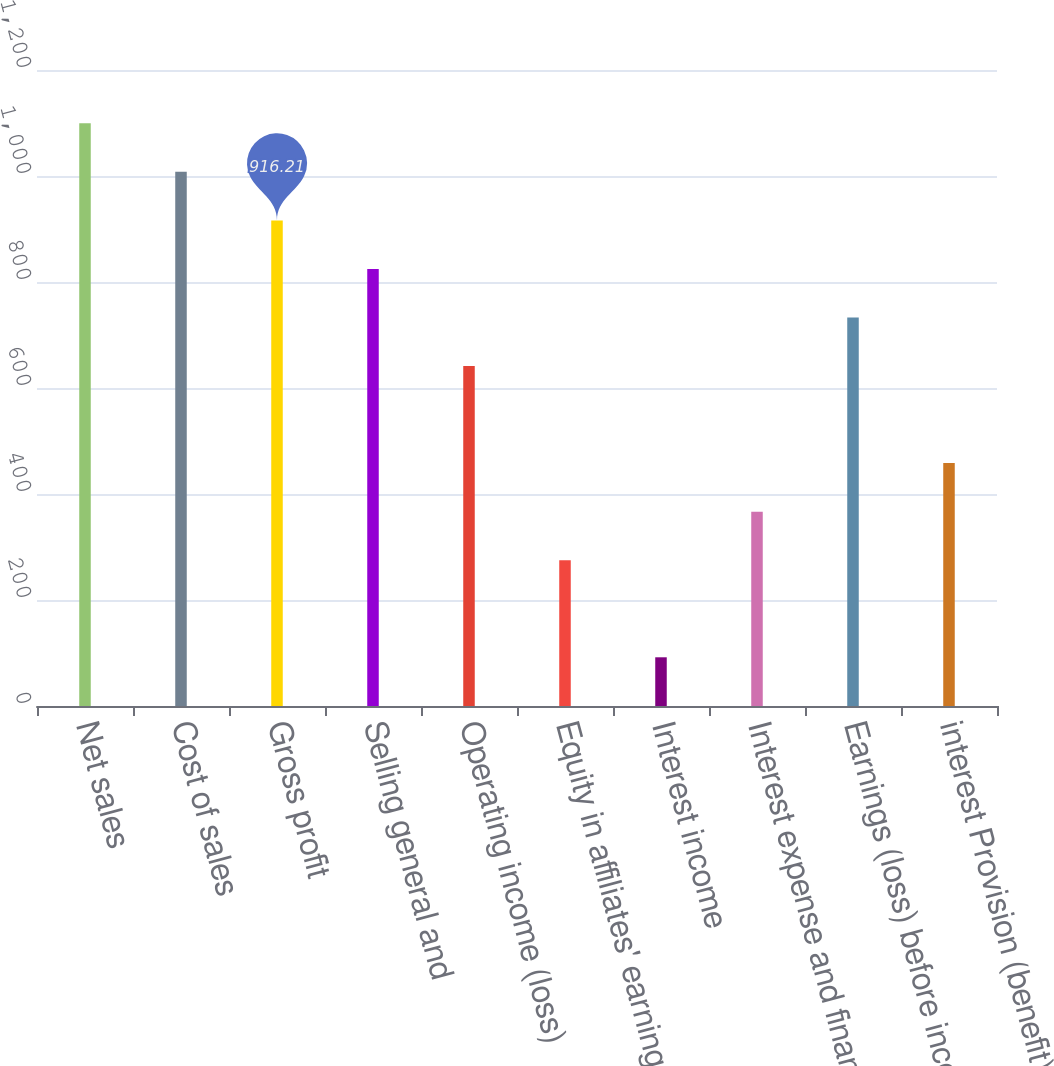Convert chart to OTSL. <chart><loc_0><loc_0><loc_500><loc_500><bar_chart><fcel>Net sales<fcel>Cost of sales<fcel>Gross profit<fcel>Selling general and<fcel>Operating income (loss)<fcel>Equity in affiliates' earnings<fcel>Interest income<fcel>Interest expense and finance<fcel>Earnings (loss) before income<fcel>interest Provision (benefit)<nl><fcel>1099.39<fcel>1007.8<fcel>916.21<fcel>824.62<fcel>641.44<fcel>275.08<fcel>91.9<fcel>366.67<fcel>733.03<fcel>458.26<nl></chart> 